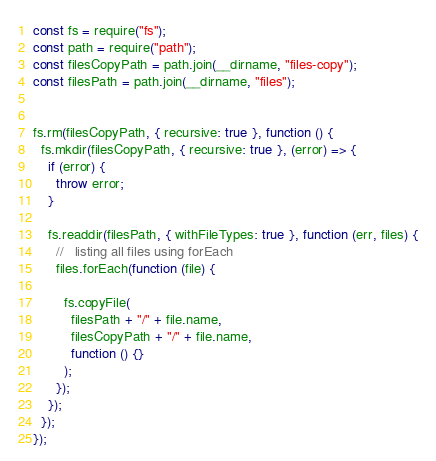<code> <loc_0><loc_0><loc_500><loc_500><_JavaScript_>const fs = require("fs");
const path = require("path");
const filesCopyPath = path.join(__dirname, "files-copy");
const filesPath = path.join(__dirname, "files");


fs.rm(filesCopyPath, { recursive: true }, function () {
  fs.mkdir(filesCopyPath, { recursive: true }, (error) => {
    if (error) {
      throw error;
    }

    fs.readdir(filesPath, { withFileTypes: true }, function (err, files) {
      //   listing all files using forEach
      files.forEach(function (file) {
        
        fs.copyFile(
          filesPath + "/" + file.name,
          filesCopyPath + "/" + file.name,
          function () {}
        );      
      });
    });
  });
});



</code> 